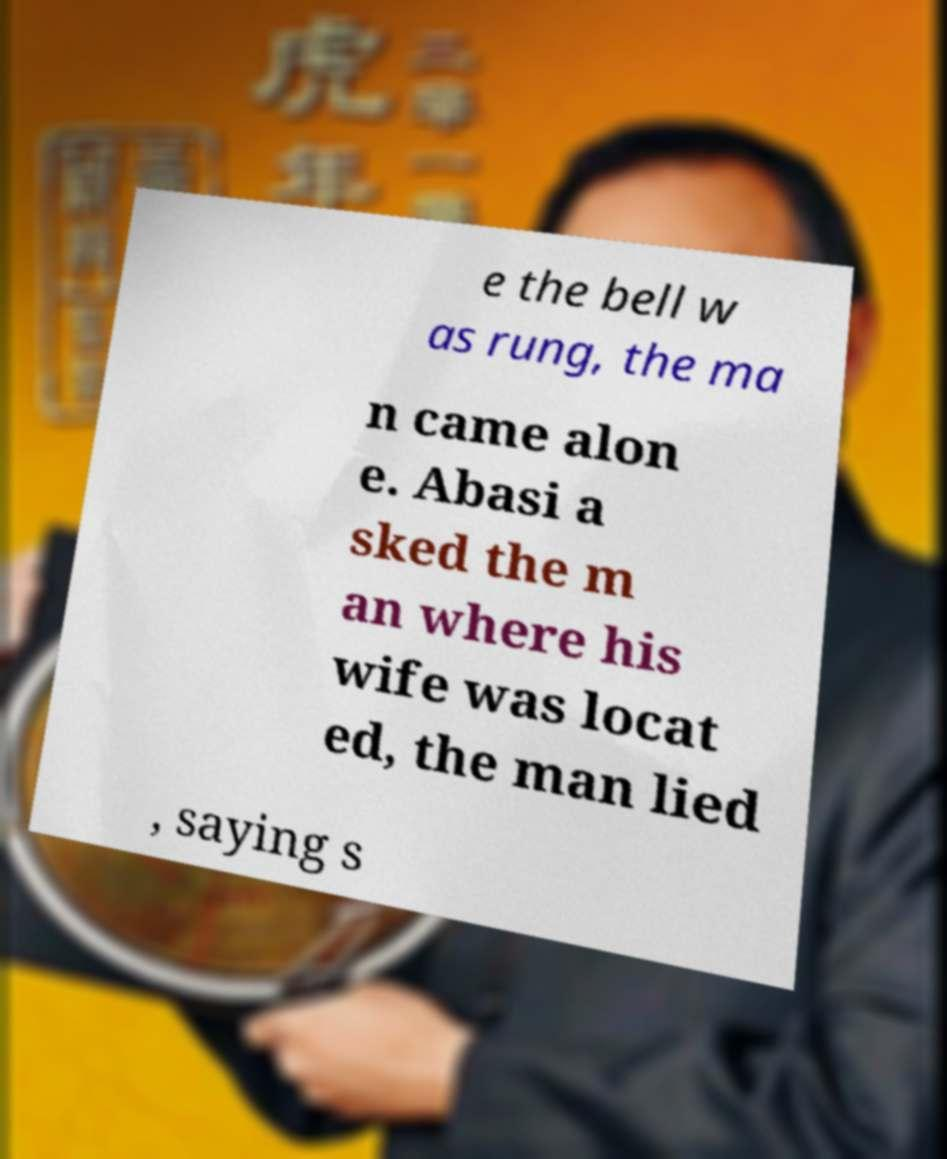Can you accurately transcribe the text from the provided image for me? e the bell w as rung, the ma n came alon e. Abasi a sked the m an where his wife was locat ed, the man lied , saying s 